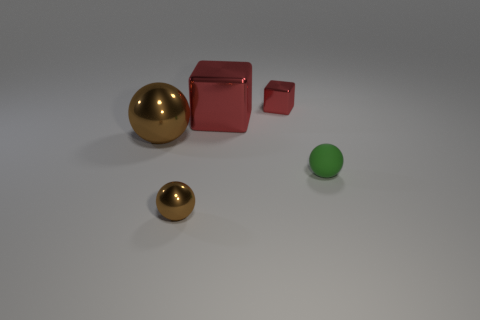What is the size of the green ball?
Give a very brief answer. Small. There is a big sphere that is the same material as the large red object; what is its color?
Your answer should be compact. Brown. How many large red things have the same material as the big ball?
Ensure brevity in your answer.  1. How many things are either tiny brown things or shiny objects that are in front of the big red metal object?
Ensure brevity in your answer.  2. Does the cube that is behind the big metal cube have the same material as the tiny green thing?
Offer a terse response. No. What color is the cube that is the same size as the green rubber object?
Ensure brevity in your answer.  Red. Are there any big brown things that have the same shape as the tiny brown metal thing?
Your answer should be very brief. Yes. What color is the metal sphere that is behind the brown thing right of the brown metal sphere behind the green thing?
Keep it short and to the point. Brown. What number of rubber objects are either big things or large blue blocks?
Your answer should be very brief. 0. Are there more matte objects that are right of the tiny green sphere than large red shiny things in front of the large metal ball?
Your answer should be very brief. No. 